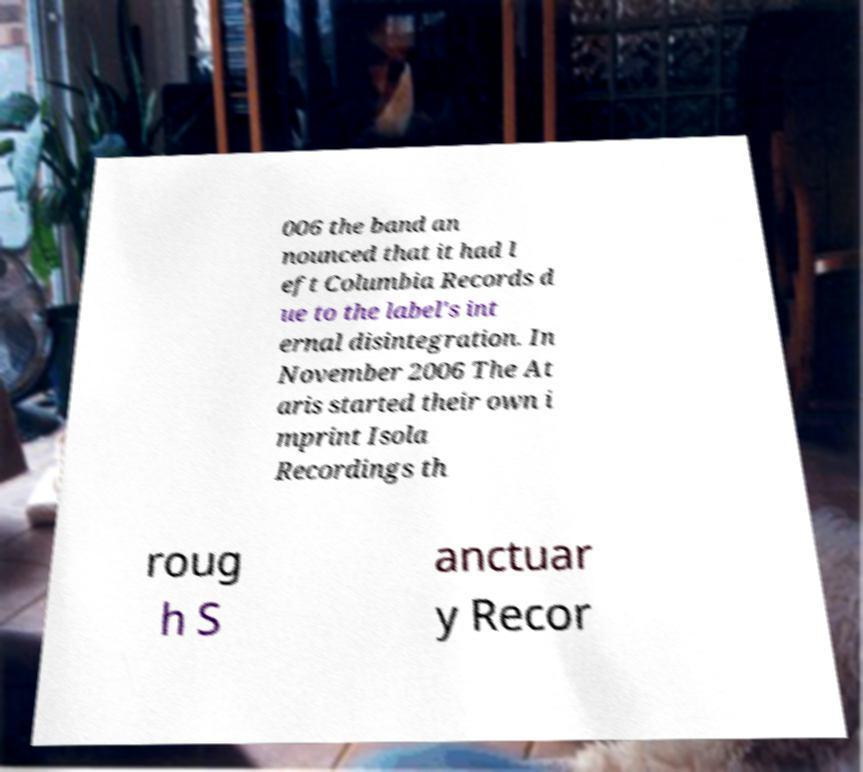Can you accurately transcribe the text from the provided image for me? 006 the band an nounced that it had l eft Columbia Records d ue to the label's int ernal disintegration. In November 2006 The At aris started their own i mprint Isola Recordings th roug h S anctuar y Recor 